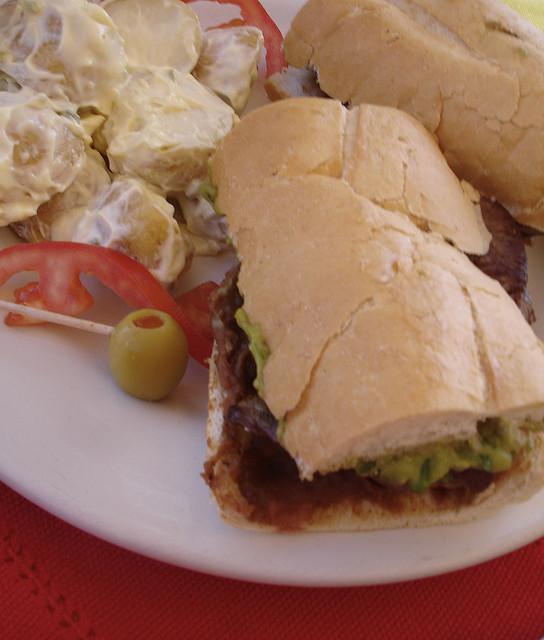How many sandwiches are in the photo?
Give a very brief answer. 2. 